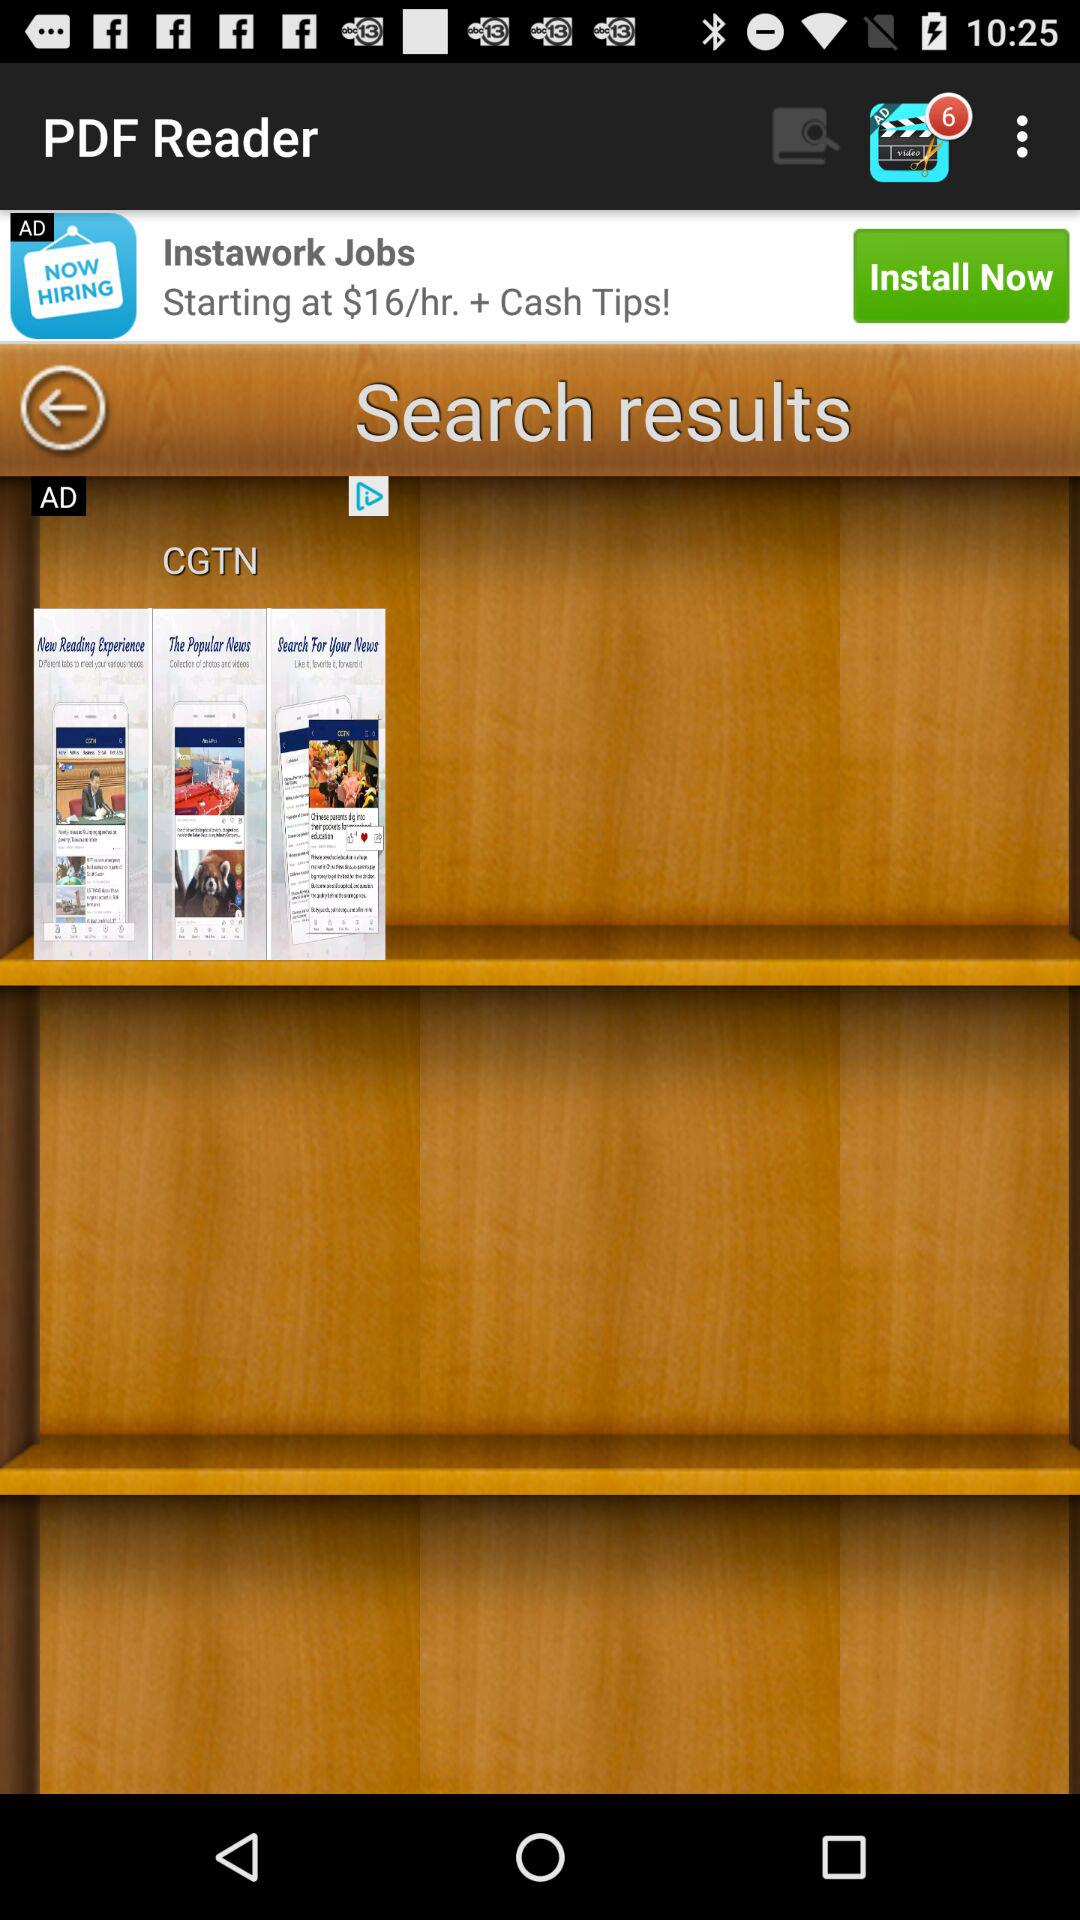How many notifications are pending? There are six pending notifications. 